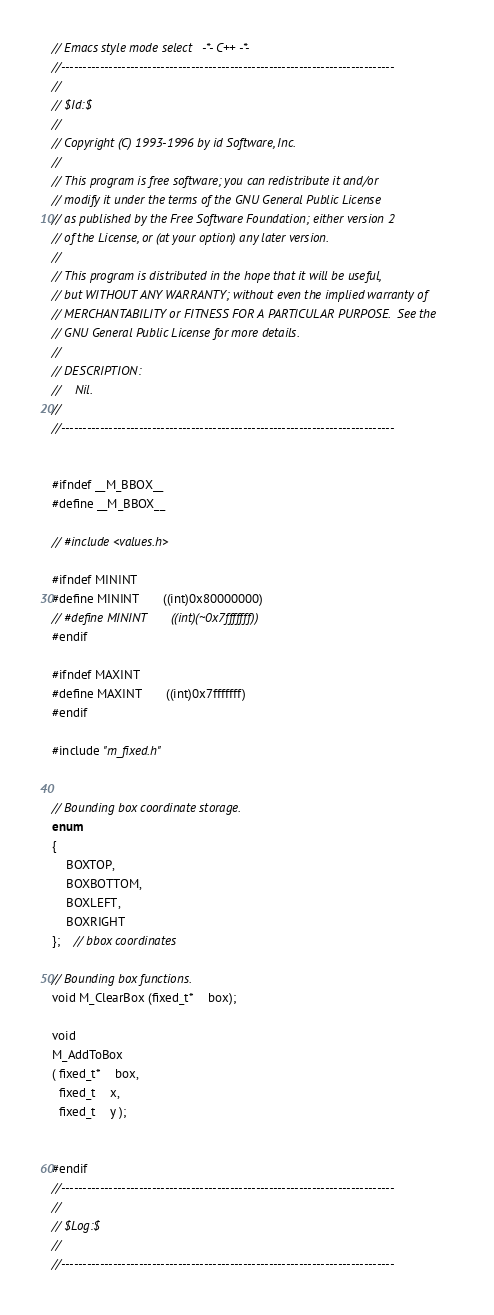Convert code to text. <code><loc_0><loc_0><loc_500><loc_500><_C_>// Emacs style mode select   -*- C++ -*- 
//-----------------------------------------------------------------------------
//
// $Id:$
//
// Copyright (C) 1993-1996 by id Software, Inc.
//
// This program is free software; you can redistribute it and/or
// modify it under the terms of the GNU General Public License
// as published by the Free Software Foundation; either version 2
// of the License, or (at your option) any later version.
//
// This program is distributed in the hope that it will be useful,
// but WITHOUT ANY WARRANTY; without even the implied warranty of
// MERCHANTABILITY or FITNESS FOR A PARTICULAR PURPOSE.  See the
// GNU General Public License for more details.
//
// DESCRIPTION:
//    Nil.
//    
//-----------------------------------------------------------------------------


#ifndef __M_BBOX__
#define __M_BBOX__

// #include <values.h>

#ifndef MININT
#define MININT		((int)0x80000000)	
// #define MININT		((int)(~0x7fffffff))	
#endif

#ifndef MAXINT
#define MAXINT		((int)0x7fffffff)	
#endif

#include "m_fixed.h"


// Bounding box coordinate storage.
enum
{
    BOXTOP,
    BOXBOTTOM,
    BOXLEFT,
    BOXRIGHT
};	// bbox coordinates

// Bounding box functions.
void M_ClearBox (fixed_t*	box);

void
M_AddToBox
( fixed_t*	box,
  fixed_t	x,
  fixed_t	y );


#endif
//-----------------------------------------------------------------------------
//
// $Log:$
//
//-----------------------------------------------------------------------------
</code> 